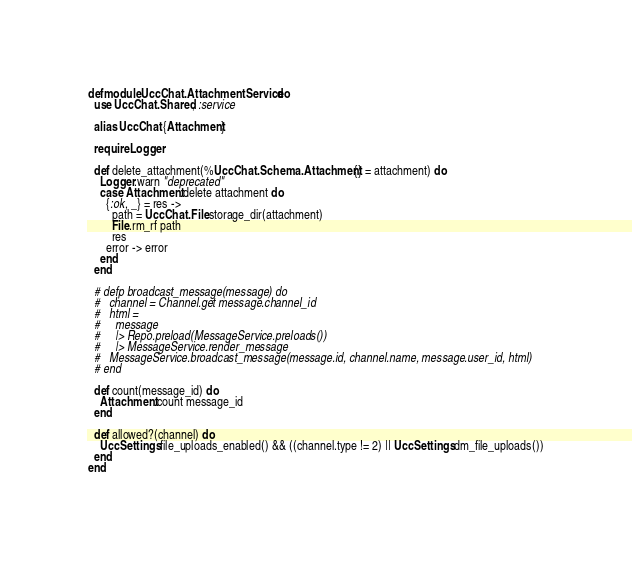Convert code to text. <code><loc_0><loc_0><loc_500><loc_500><_Elixir_>defmodule UccChat.AttachmentService do
  use UccChat.Shared, :service

  alias UccChat.{Attachment}

  require Logger

  def delete_attachment(%UccChat.Schema.Attachment{} = attachment) do
    Logger.warn "deprecated"
    case Attachment.delete attachment do
      {:ok, _} = res ->
        path = UccChat.File.storage_dir(attachment)
        File.rm_rf path
        res
      error -> error
    end
  end

  # defp broadcast_message(message) do
  #   channel = Channel.get message.channel_id
  #   html =
  #     message
  #     |> Repo.preload(MessageService.preloads())
  #     |> MessageService.render_message
  #   MessageService.broadcast_message(message.id, channel.name, message.user_id, html)
  # end

  def count(message_id) do
    Attachment.count message_id
  end

  def allowed?(channel) do
    UccSettings.file_uploads_enabled() && ((channel.type != 2) || UccSettings.dm_file_uploads())
  end
end
</code> 